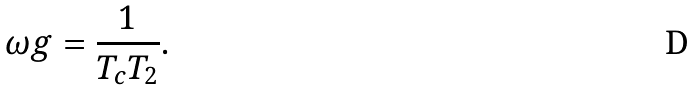<formula> <loc_0><loc_0><loc_500><loc_500>\omega g = \frac { 1 } { T _ { c } T _ { 2 } } .</formula> 